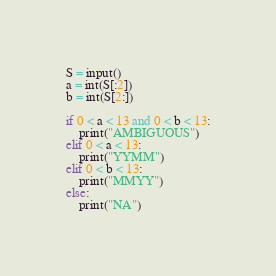<code> <loc_0><loc_0><loc_500><loc_500><_Python_>S = input()
a = int(S[:2])
b = int(S[2:])

if 0 < a < 13 and 0 < b < 13:
    print("AMBIGUOUS")
elif 0 < a < 13:
    print("YYMM")
elif 0 < b < 13:
    print("MMYY")
else:
    print("NA")
</code> 